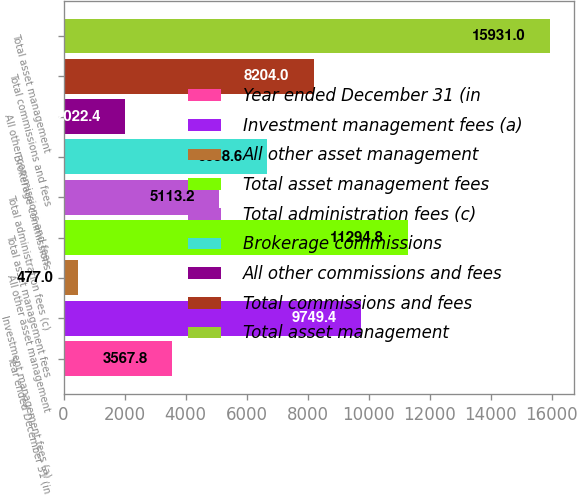Convert chart to OTSL. <chart><loc_0><loc_0><loc_500><loc_500><bar_chart><fcel>Year ended December 31 (in<fcel>Investment management fees (a)<fcel>All other asset management<fcel>Total asset management fees<fcel>Total administration fees (c)<fcel>Brokerage commissions<fcel>All other commissions and fees<fcel>Total commissions and fees<fcel>Total asset management<nl><fcel>3567.8<fcel>9749.4<fcel>477<fcel>11294.8<fcel>5113.2<fcel>6658.6<fcel>2022.4<fcel>8204<fcel>15931<nl></chart> 